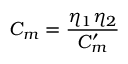<formula> <loc_0><loc_0><loc_500><loc_500>C _ { m } = \frac { \eta _ { 1 } \eta _ { 2 } } { C _ { m } ^ { \prime } }</formula> 